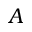Convert formula to latex. <formula><loc_0><loc_0><loc_500><loc_500>A</formula> 